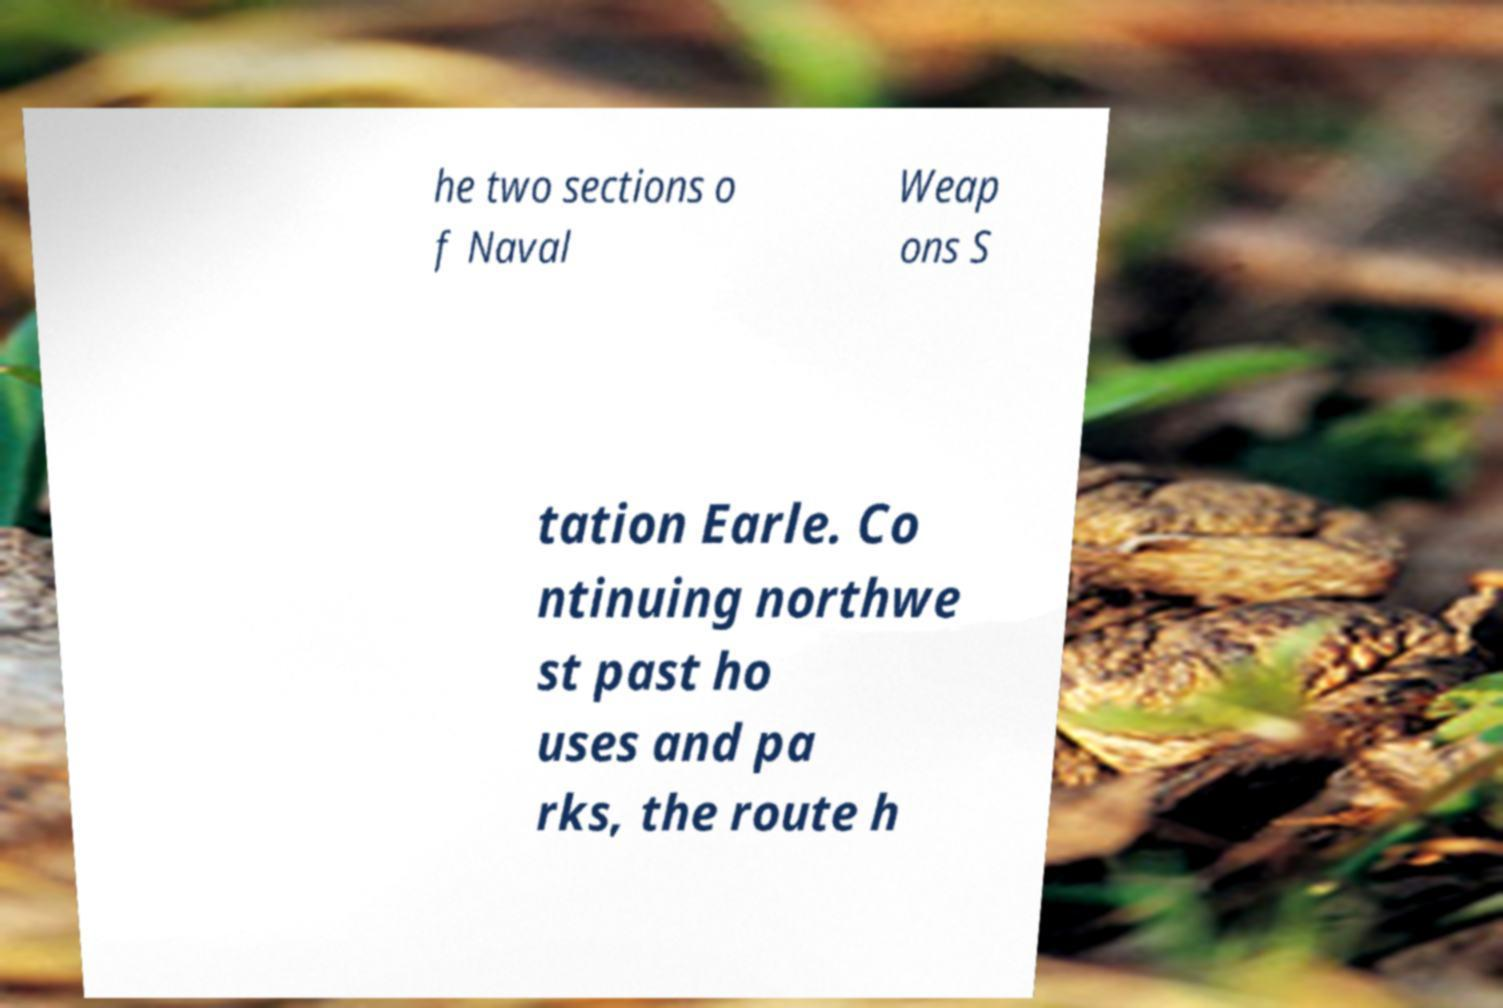Could you assist in decoding the text presented in this image and type it out clearly? he two sections o f Naval Weap ons S tation Earle. Co ntinuing northwe st past ho uses and pa rks, the route h 